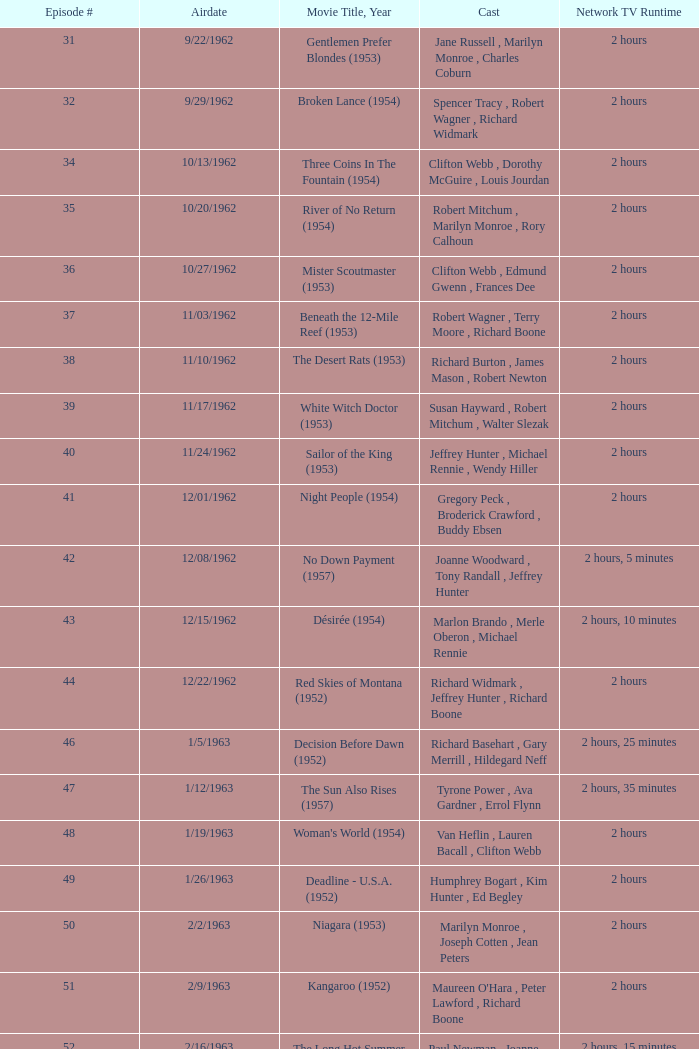How many runtimes does episode 53 have? 1.0. 